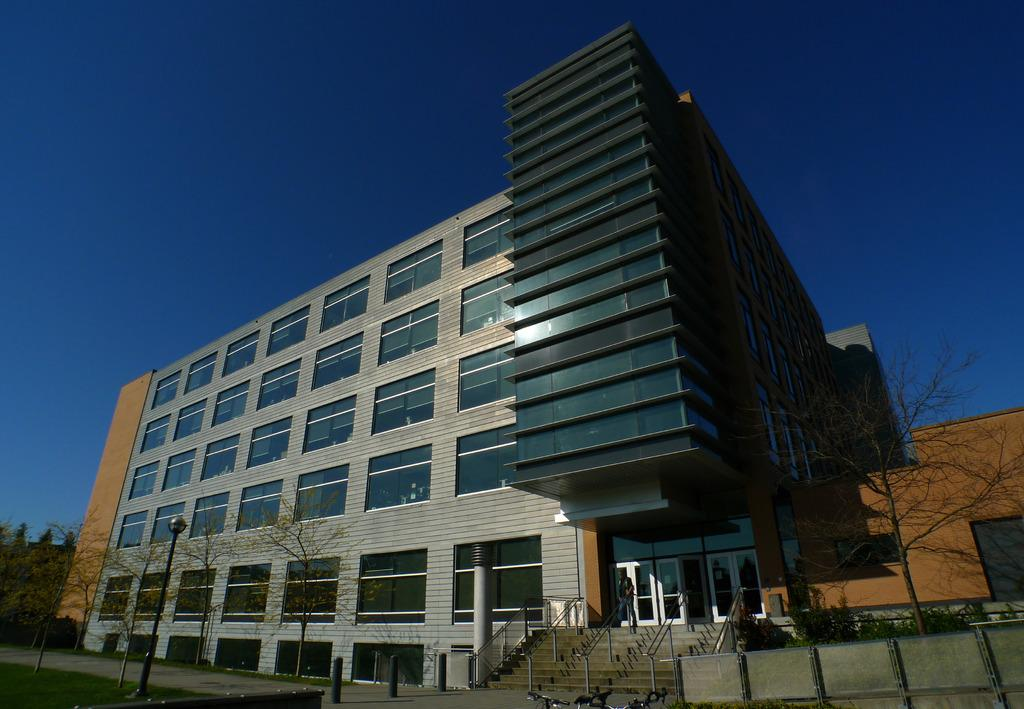What type of windows does the building have in the image? The building has glass windows in the image. Can you describe the person in the image? There is a person in the image, but no specific details about their appearance or actions are provided. What architectural feature is present in the image? There are steps in the image. What is the purpose of the light pole in the image? The light pole is likely used for illumination purposes. What type of vegetation is present in the image? Plants and trees are present in the image. What is the color of the sky in the image? The sky is blue in color. How many pins are visible on the person's clothing in the image? There is no mention of pins or any specific details about the person's clothing in the image. What type of boats can be seen in the image? There are no boats present in the image. What instrument is the person playing in the image? There is no indication of a drum or any musical instrument being played in the image. 